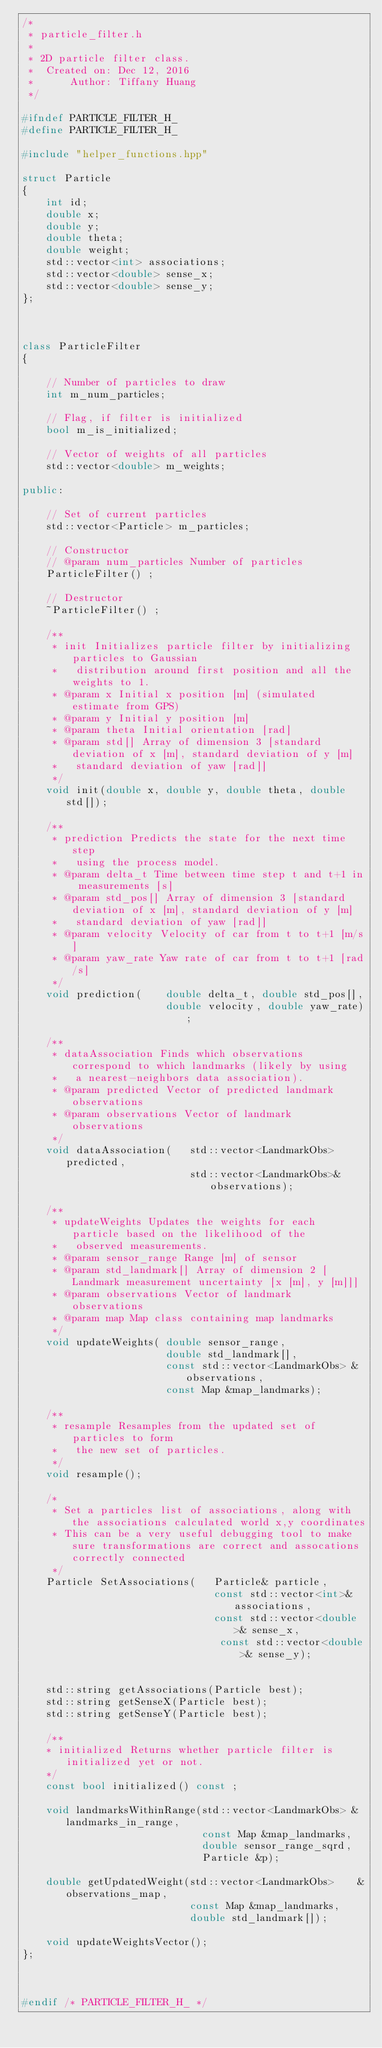Convert code to text. <code><loc_0><loc_0><loc_500><loc_500><_C++_>/*
 * particle_filter.h
 *
 * 2D particle filter class.
 *  Created on: Dec 12, 2016
 *      Author: Tiffany Huang
 */

#ifndef PARTICLE_FILTER_H_
#define PARTICLE_FILTER_H_

#include "helper_functions.hpp"

struct Particle 
{
	int id;
	double x;
	double y;
	double theta;
	double weight;
	std::vector<int> associations;
	std::vector<double> sense_x;
	std::vector<double> sense_y;
};



class ParticleFilter 
{
	
	// Number of particles to draw
	int m_num_particles; 

	// Flag, if filter is initialized
	bool m_is_initialized;
	
	// Vector of weights of all particles
	std::vector<double> m_weights;
	
public:
	
	// Set of current particles
	std::vector<Particle> m_particles;

	// Constructor
	// @param num_particles Number of particles
	ParticleFilter() ;

	// Destructor
	~ParticleFilter() ;

	/**
	 * init Initializes particle filter by initializing particles to Gaussian
	 *   distribution around first position and all the weights to 1.
	 * @param x Initial x position [m] (simulated estimate from GPS)
	 * @param y Initial y position [m]
	 * @param theta Initial orientation [rad]
	 * @param std[] Array of dimension 3 [standard deviation of x [m], standard deviation of y [m]
	 *   standard deviation of yaw [rad]]
	 */
	void init(double x, double y, double theta, double std[]);

	/**
	 * prediction Predicts the state for the next time step
	 *   using the process model.
	 * @param delta_t Time between time step t and t+1 in measurements [s]
	 * @param std_pos[] Array of dimension 3 [standard deviation of x [m], standard deviation of y [m]
	 *   standard deviation of yaw [rad]]
	 * @param velocity Velocity of car from t to t+1 [m/s]
	 * @param yaw_rate Yaw rate of car from t to t+1 [rad/s]
	 */
	void prediction(	double delta_t, double std_pos[], 
						double velocity, double yaw_rate);
	
	/**
	 * dataAssociation Finds which observations correspond to which landmarks (likely by using
	 *   a nearest-neighbors data association).
	 * @param predicted Vector of predicted landmark observations
	 * @param observations Vector of landmark observations
	 */
	void dataAssociation(	std::vector<LandmarkObs> predicted, 
							std::vector<LandmarkObs>& observations);
	
	/**
	 * updateWeights Updates the weights for each particle based on the likelihood of the 
	 *   observed measurements. 
	 * @param sensor_range Range [m] of sensor
	 * @param std_landmark[] Array of dimension 2 [Landmark measurement uncertainty [x [m], y [m]]]
	 * @param observations Vector of landmark observations
	 * @param map Map class containing map landmarks
	 */
	void updateWeights(	double sensor_range, 
						double std_landmark[], 
						const std::vector<LandmarkObs> &observations,
						const Map &map_landmarks);
	
	/**
	 * resample Resamples from the updated set of particles to form
	 *   the new set of particles.
	 */
	void resample();

	/*
	 * Set a particles list of associations, along with the associations calculated world x,y coordinates
	 * This can be a very useful debugging tool to make sure transformations are correct and assocations correctly connected
	 */
	Particle SetAssociations(	Particle& particle, 
								const std::vector<int>& associations,
		                     	const std::vector<double>& sense_x, 
								 const std::vector<double>& sense_y);

	
	std::string getAssociations(Particle best);
	std::string getSenseX(Particle best);
	std::string getSenseY(Particle best);

	/**
	* initialized Returns whether particle filter is initialized yet or not.
	*/
	const bool initialized() const ;
	
    void landmarksWithinRange(std::vector<LandmarkObs> &landmarks_in_range,
                              const Map &map_landmarks,
                              double sensor_range_sqrd,
                              Particle &p);

    double getUpdatedWeight(std::vector<LandmarkObs>    &observations_map,
                            const Map &map_landmarks,
                            double std_landmark[]);

    void updateWeightsVector();
};



#endif /* PARTICLE_FILTER_H_ */
</code> 